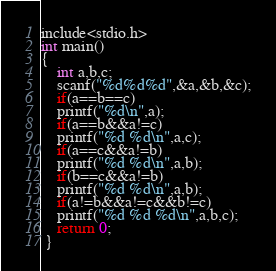<code> <loc_0><loc_0><loc_500><loc_500><_C_>include<stdio.h>
int main()
{
	int a,b,c;
	scanf("%d%d%d",&a,&b,&c);
	if(a==b==c)
	printf("%d\n",a);
    if(a==b&&a!=c)
    printf("%d %d\n",a,c);
    if(a==c&&a!=b)
    printf("%d %d\n",a,b);
    if(b==c&&a!=b)
    printf("%d %d\n",a,b);
    if(a!=b&&a!=c&&b!=c)
    printf("%d %d %d\n",a,b,c);
	return 0;
 } </code> 